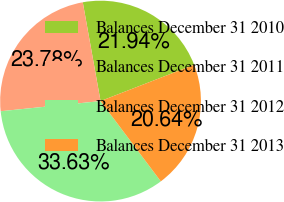<chart> <loc_0><loc_0><loc_500><loc_500><pie_chart><fcel>Balances December 31 2010<fcel>Balances December 31 2011<fcel>Balances December 31 2012<fcel>Balances December 31 2013<nl><fcel>21.94%<fcel>23.78%<fcel>33.63%<fcel>20.64%<nl></chart> 